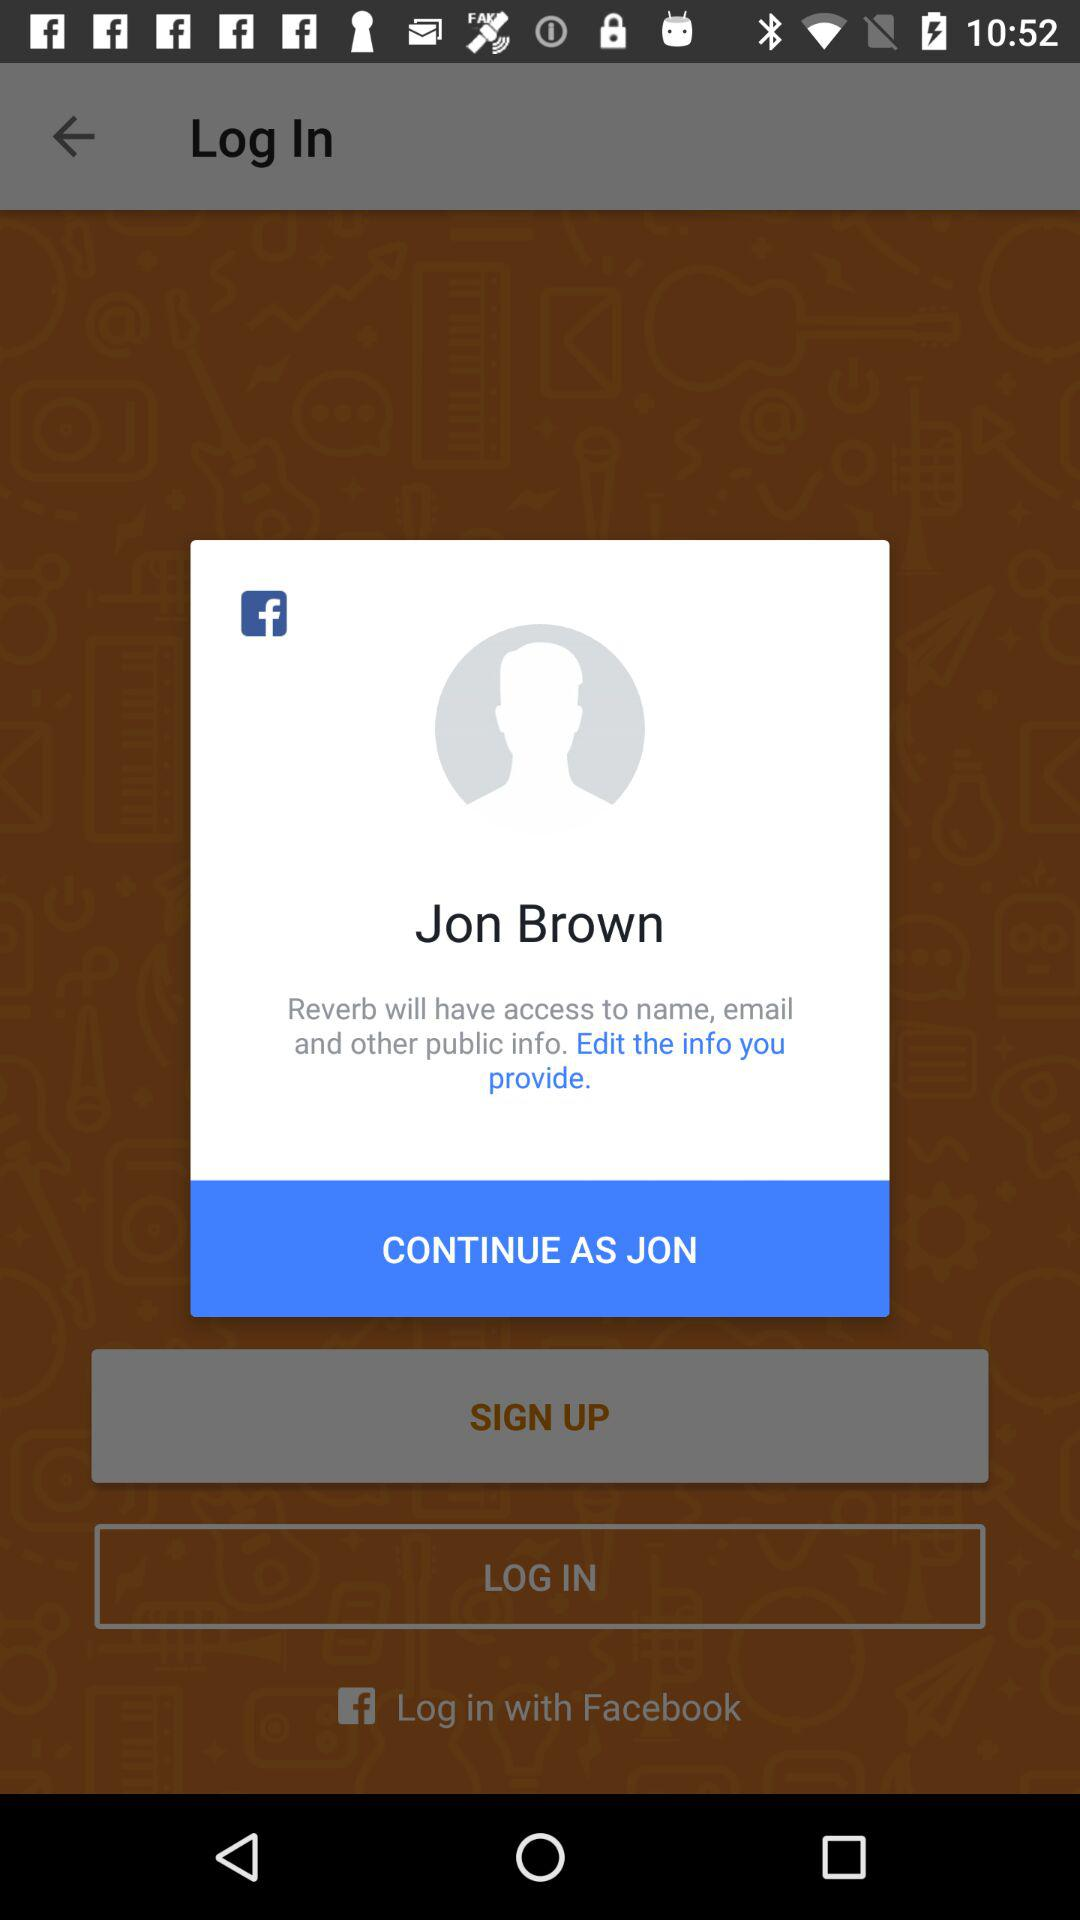What is the login name? The login name is Jon Brown. 